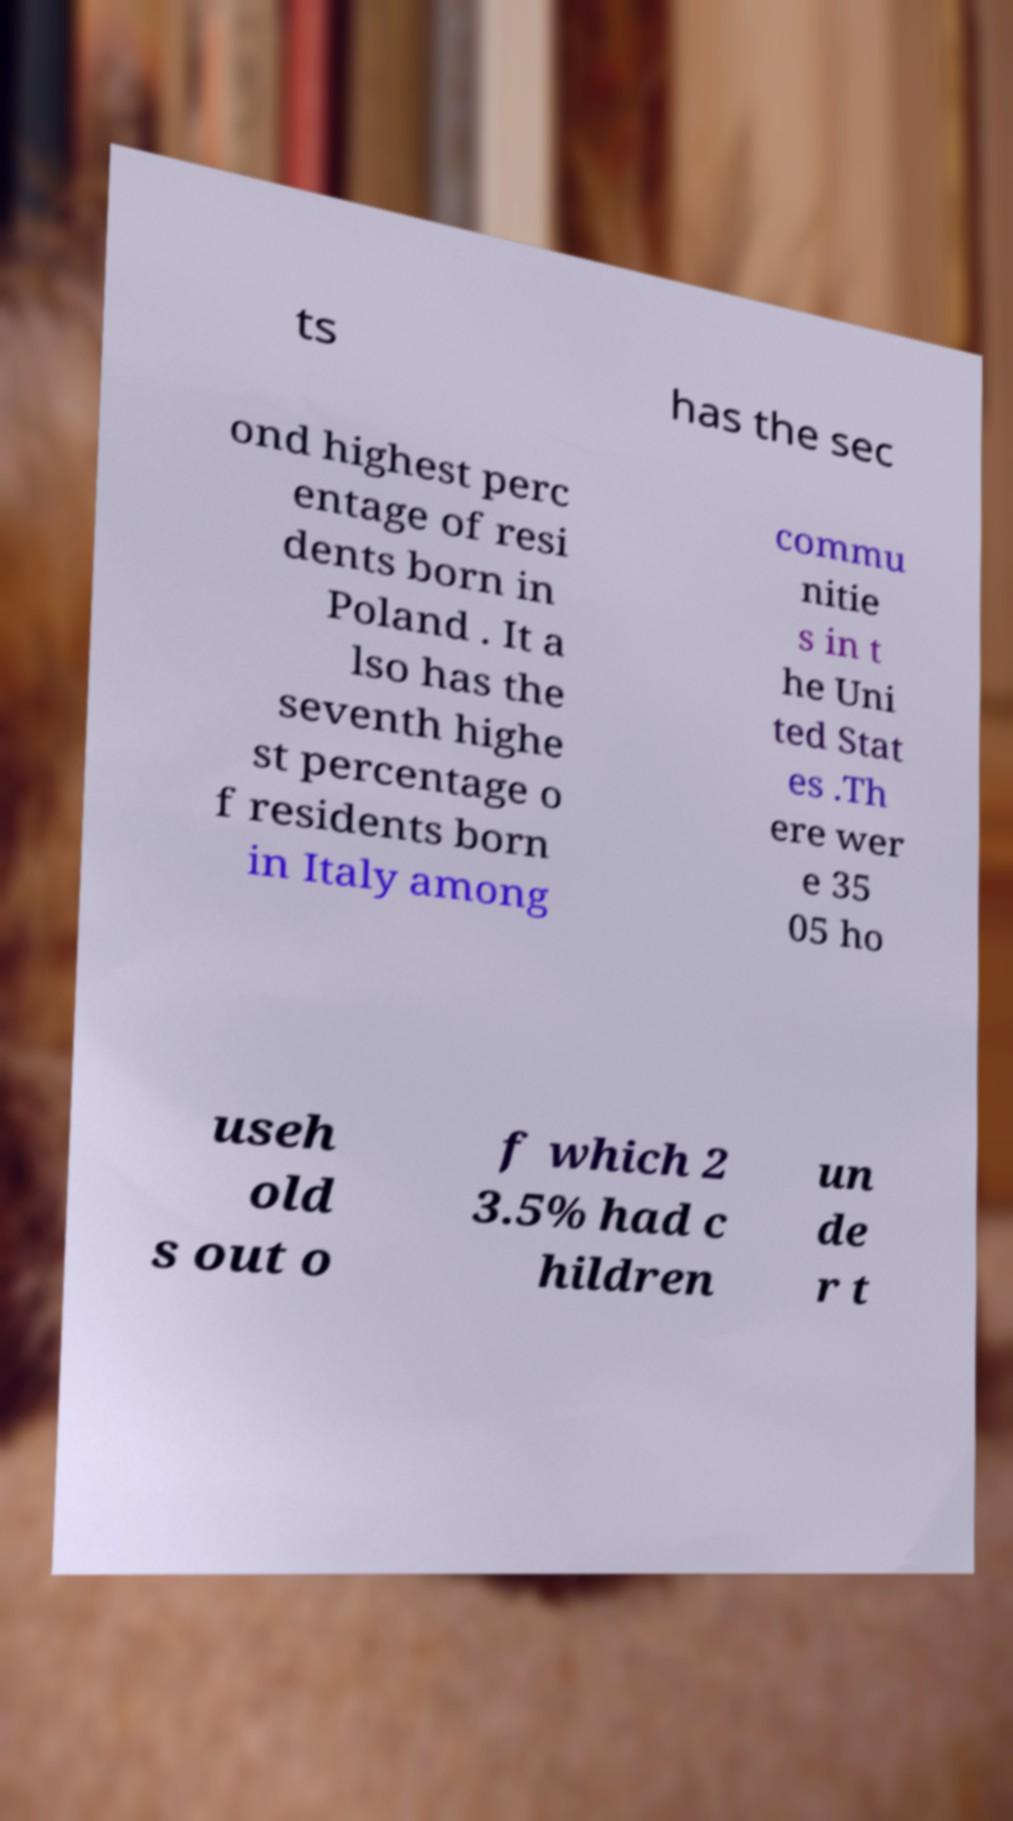Could you assist in decoding the text presented in this image and type it out clearly? ts has the sec ond highest perc entage of resi dents born in Poland . It a lso has the seventh highe st percentage o f residents born in Italy among commu nitie s in t he Uni ted Stat es .Th ere wer e 35 05 ho useh old s out o f which 2 3.5% had c hildren un de r t 